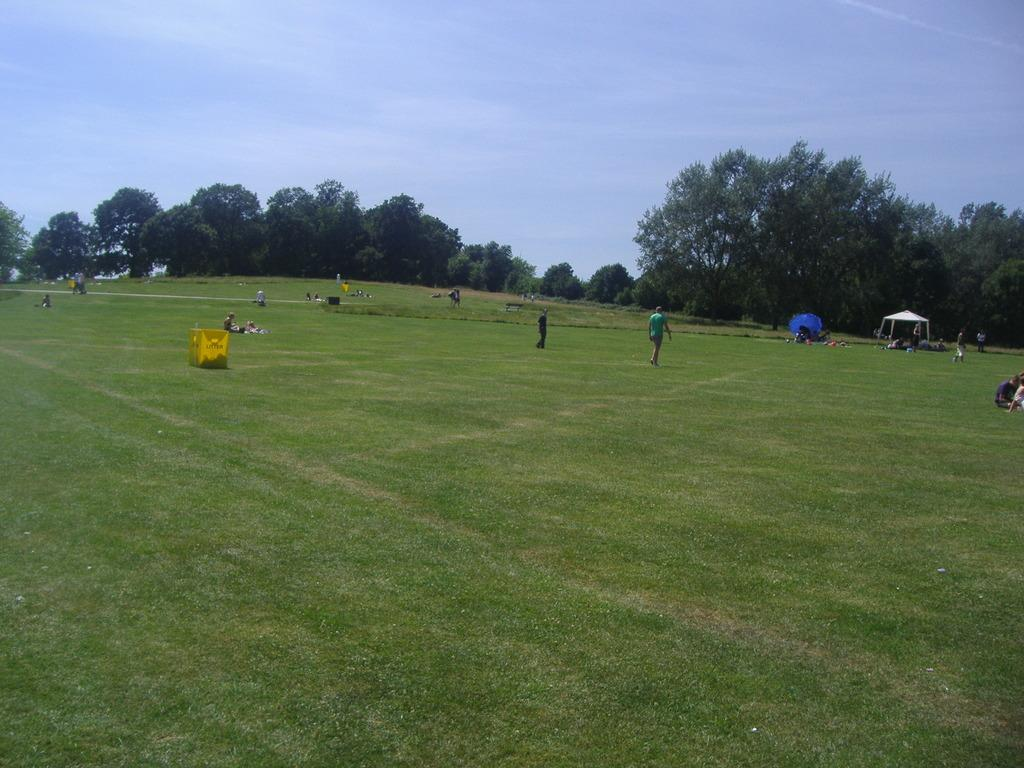Who or what can be seen in the image? There are people in the image. What are the people wearing? The people are wearing clothes. What is located in the middle of the image? There are trees in the middle of the image. What is visible at the top of the image}? The sky is visible at the top of the image}. How many fish can be seen swimming in the image? There are no fish present in the image. What type of home is visible in the background of the image? There is no home visible in the image; it only features people, trees, and the sky. 